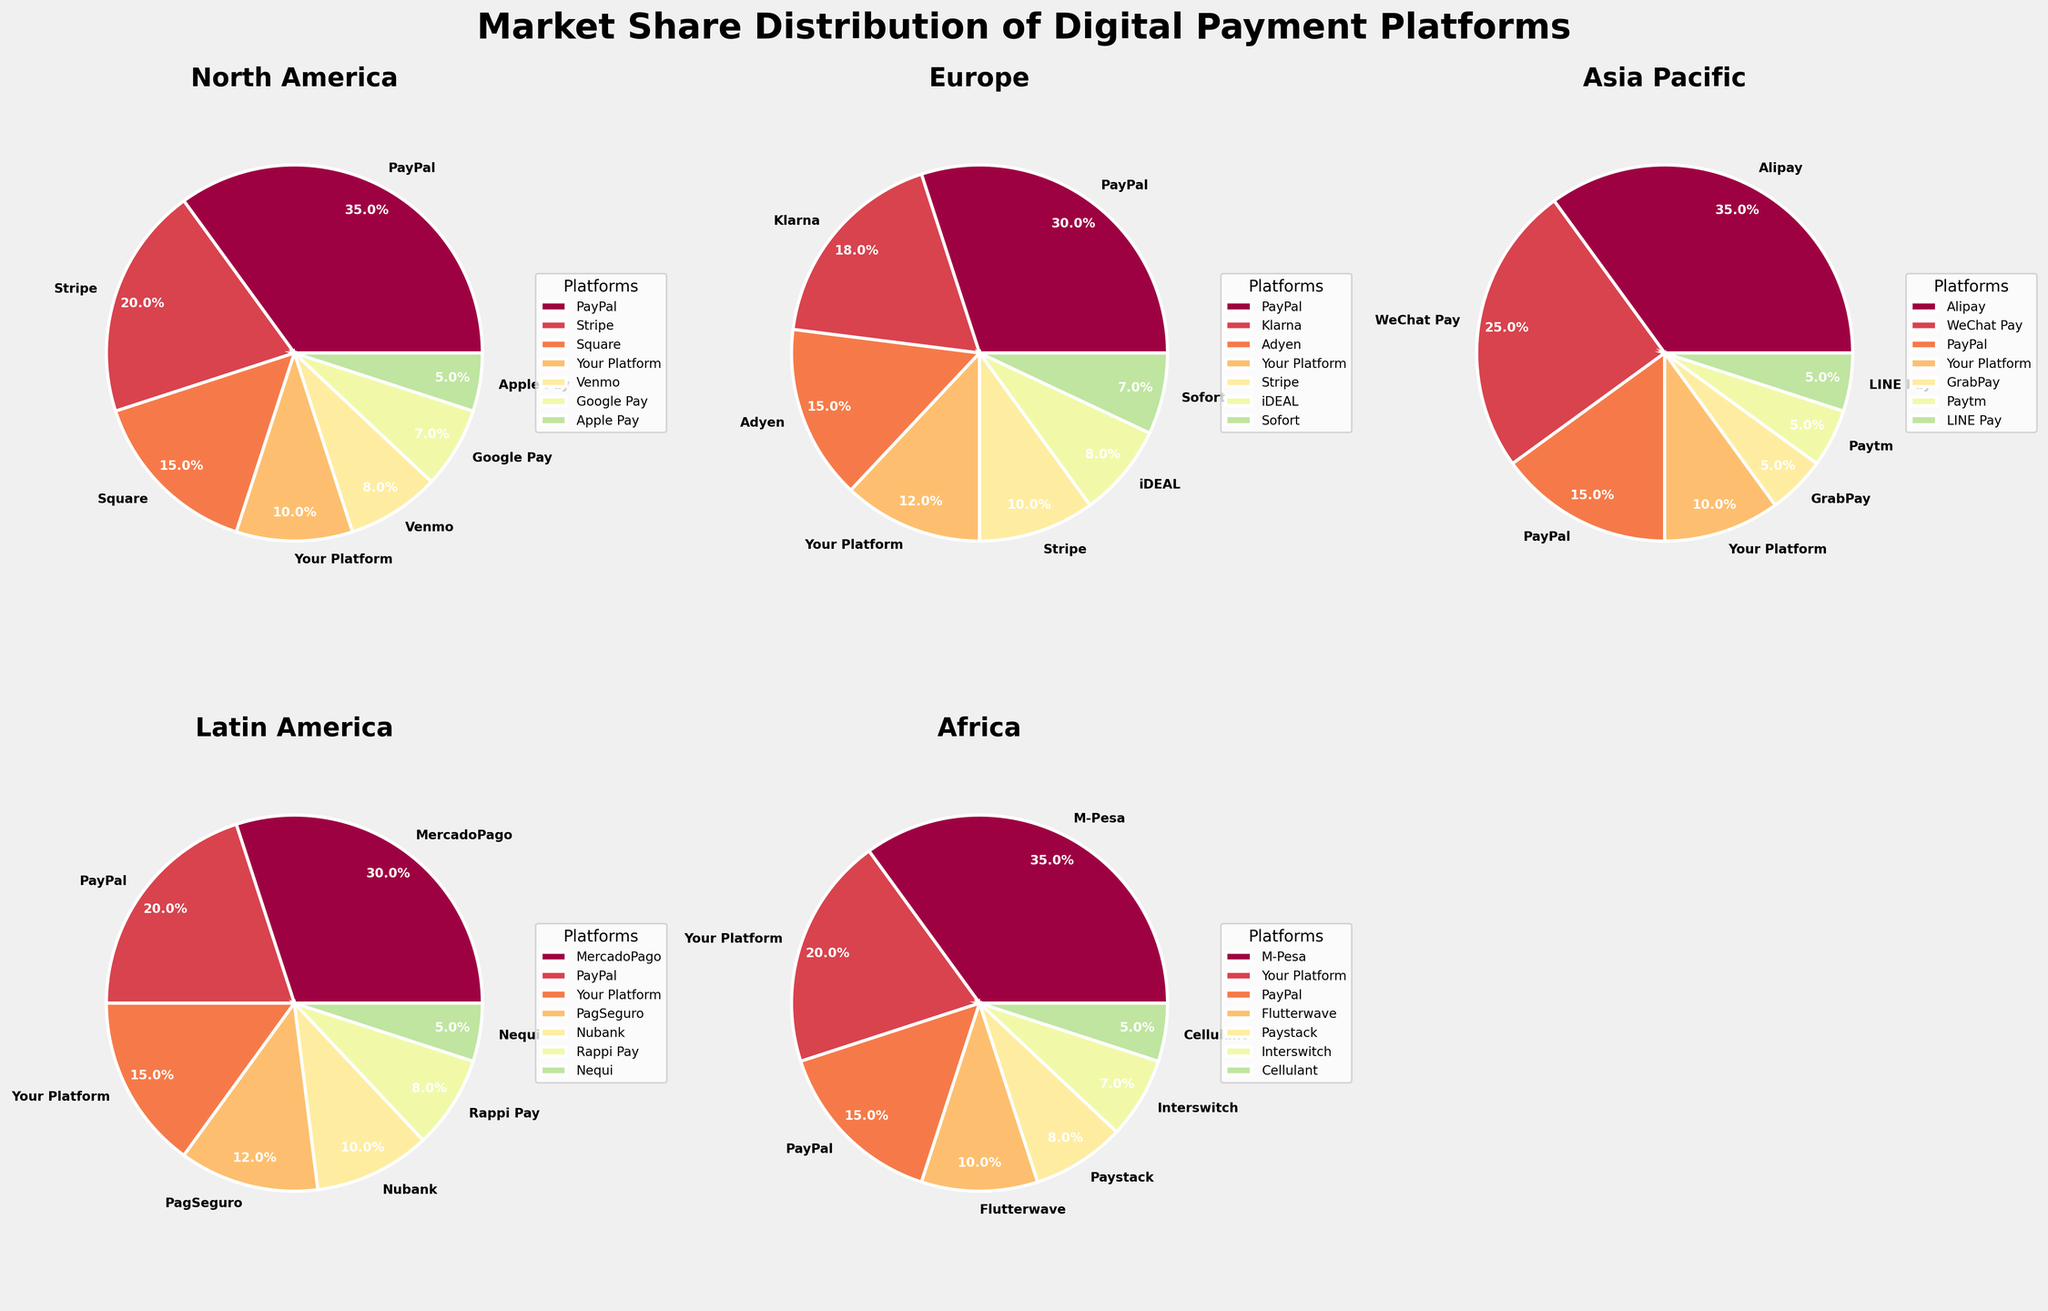What is the market share of Your Platform in Africa? Look at the pie chart for the Africa region. The segment labeled 'Your Platform' represents 20% of the market share.
Answer: 20% Which platform has the highest market share in Latin America? Look at the pie chart for the Latin America region. The largest segment is labeled 'MercadoPago', which occupies 30% of the market share.
Answer: MercadoPago In which region does Your Platform have the lowest market share? Look at the pie charts for all regions and find the smallest segment labeled 'Your Platform'. This occurs in North America, where it has a 10% market share, which is equal to its share in Asia Pacific but lower than in Europe, Latin America, and Africa.
Answer: North America Which platform has more market share in Europe, Klarna or Stripe? Look at the pie chart for the Europe region. Klarna occupies 18% of the market share, while Stripe occupies 10%. Therefore, Klarna has more market share.
Answer: Klarna What is the combined market share of Alipay and WeChat Pay in the Asia Pacific region? Refer to the pie chart for the Asia Pacific region. Alipay has 35% and WeChat Pay has 25%. Summing these together gives 35% + 25% = 60%.
Answer: 60% Which region has the smallest share for PayPal? Look at each pie chart to identify the segment labeled 'PayPal'. In Africa, PayPal has the smallest market share of all regions at 15%.
Answer: Africa What's the difference in market share between PayPal and Your Platform in North America? In the pie chart for the North America region, PayPal has a market share of 35%, while Your Platform has 10%. The difference is calculated as 35% - 10% = 25%.
Answer: 25% Which platform besides Your Platform has a notable market share in Africa? Refer to the pie chart for the Africa region. M-Pesa has the highest platform share of 35%, which is a significant portion besides Your Platform's 20%.
Answer: M-Pesa Which region shows the highest market share for the dominant platform? Look at all pie charts to find the largest segment in each region. M-Pesa in Africa has the highest single market share at 35%. Matching this, both Alipay in the Asia Pacific and PayPal in North America also have a 35% share, so all three regions are tied.
Answer: Africa, Asia Pacific, and North America What’s the combined market share of Your Platform across all regions? Add up the market share percentages of Your Platform in each region: North America (10%), Europe (12%), Asia Pacific (10%), Latin America (15%), Africa (20%). The sum is 10% + 12% + 10% + 15% + 20% = 67%.
Answer: 67% 